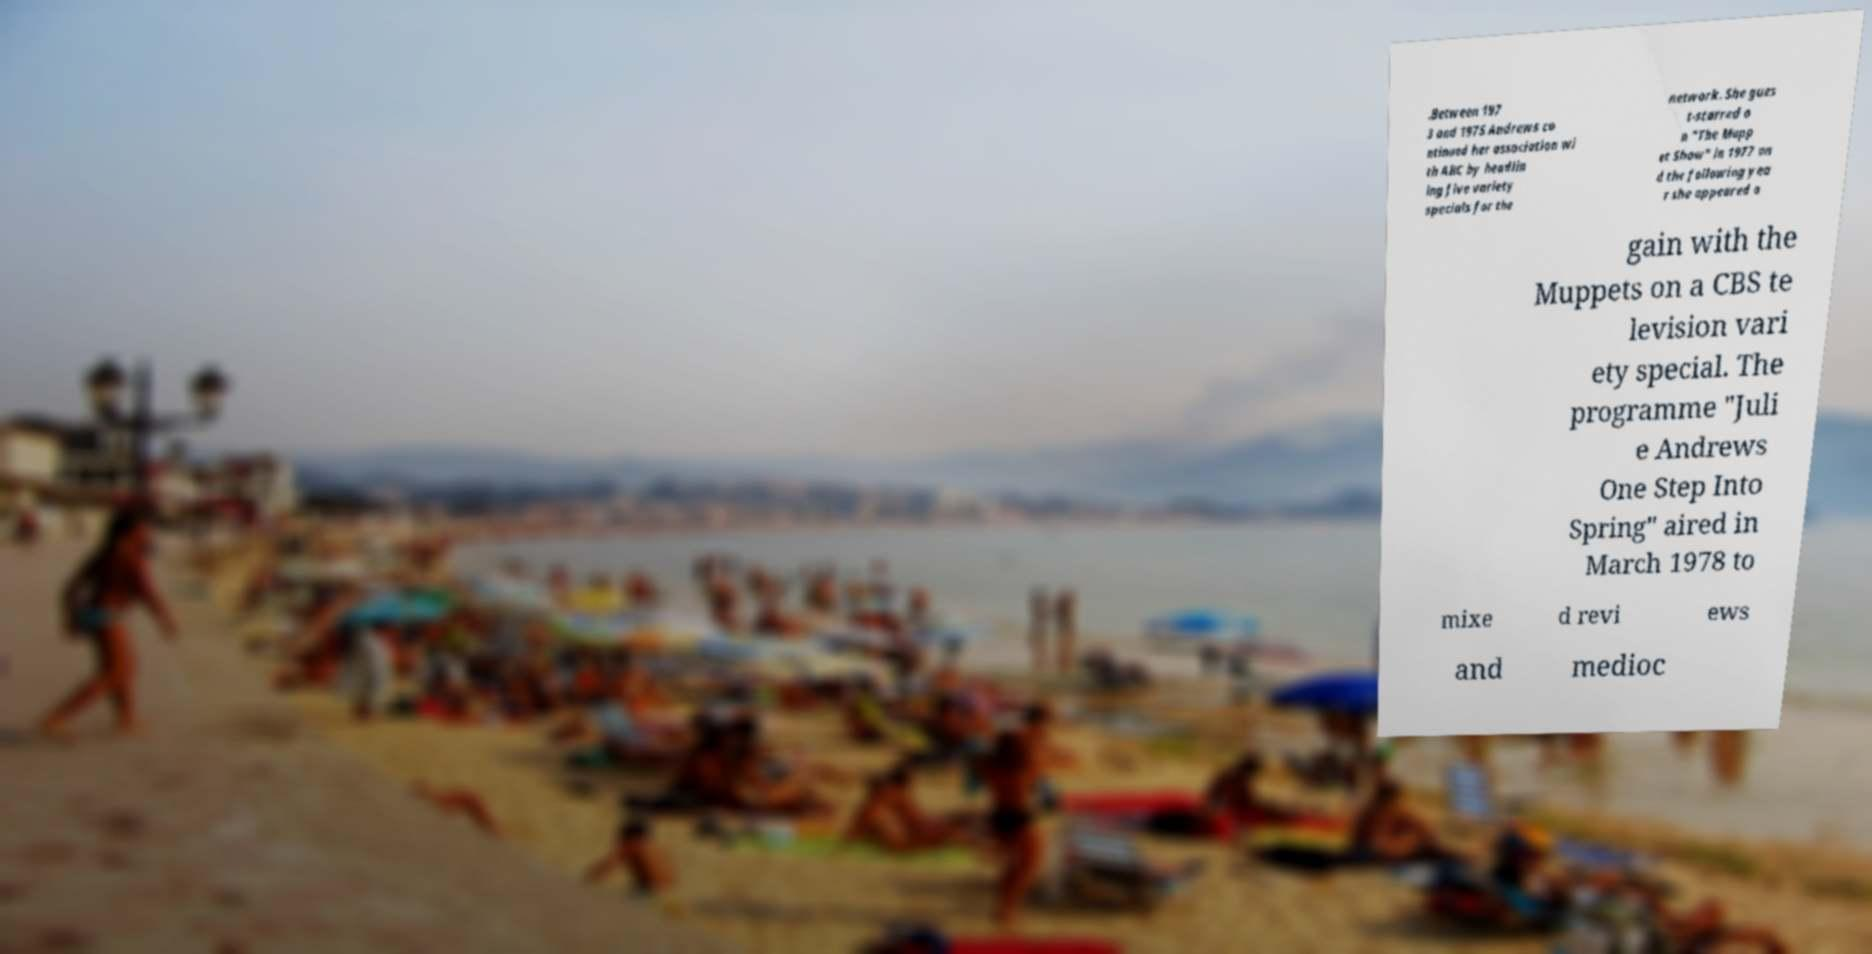Can you accurately transcribe the text from the provided image for me? .Between 197 3 and 1975 Andrews co ntinued her association wi th ABC by headlin ing five variety specials for the network. She gues t-starred o n "The Mupp et Show" in 1977 an d the following yea r she appeared a gain with the Muppets on a CBS te levision vari ety special. The programme "Juli e Andrews One Step Into Spring" aired in March 1978 to mixe d revi ews and medioc 